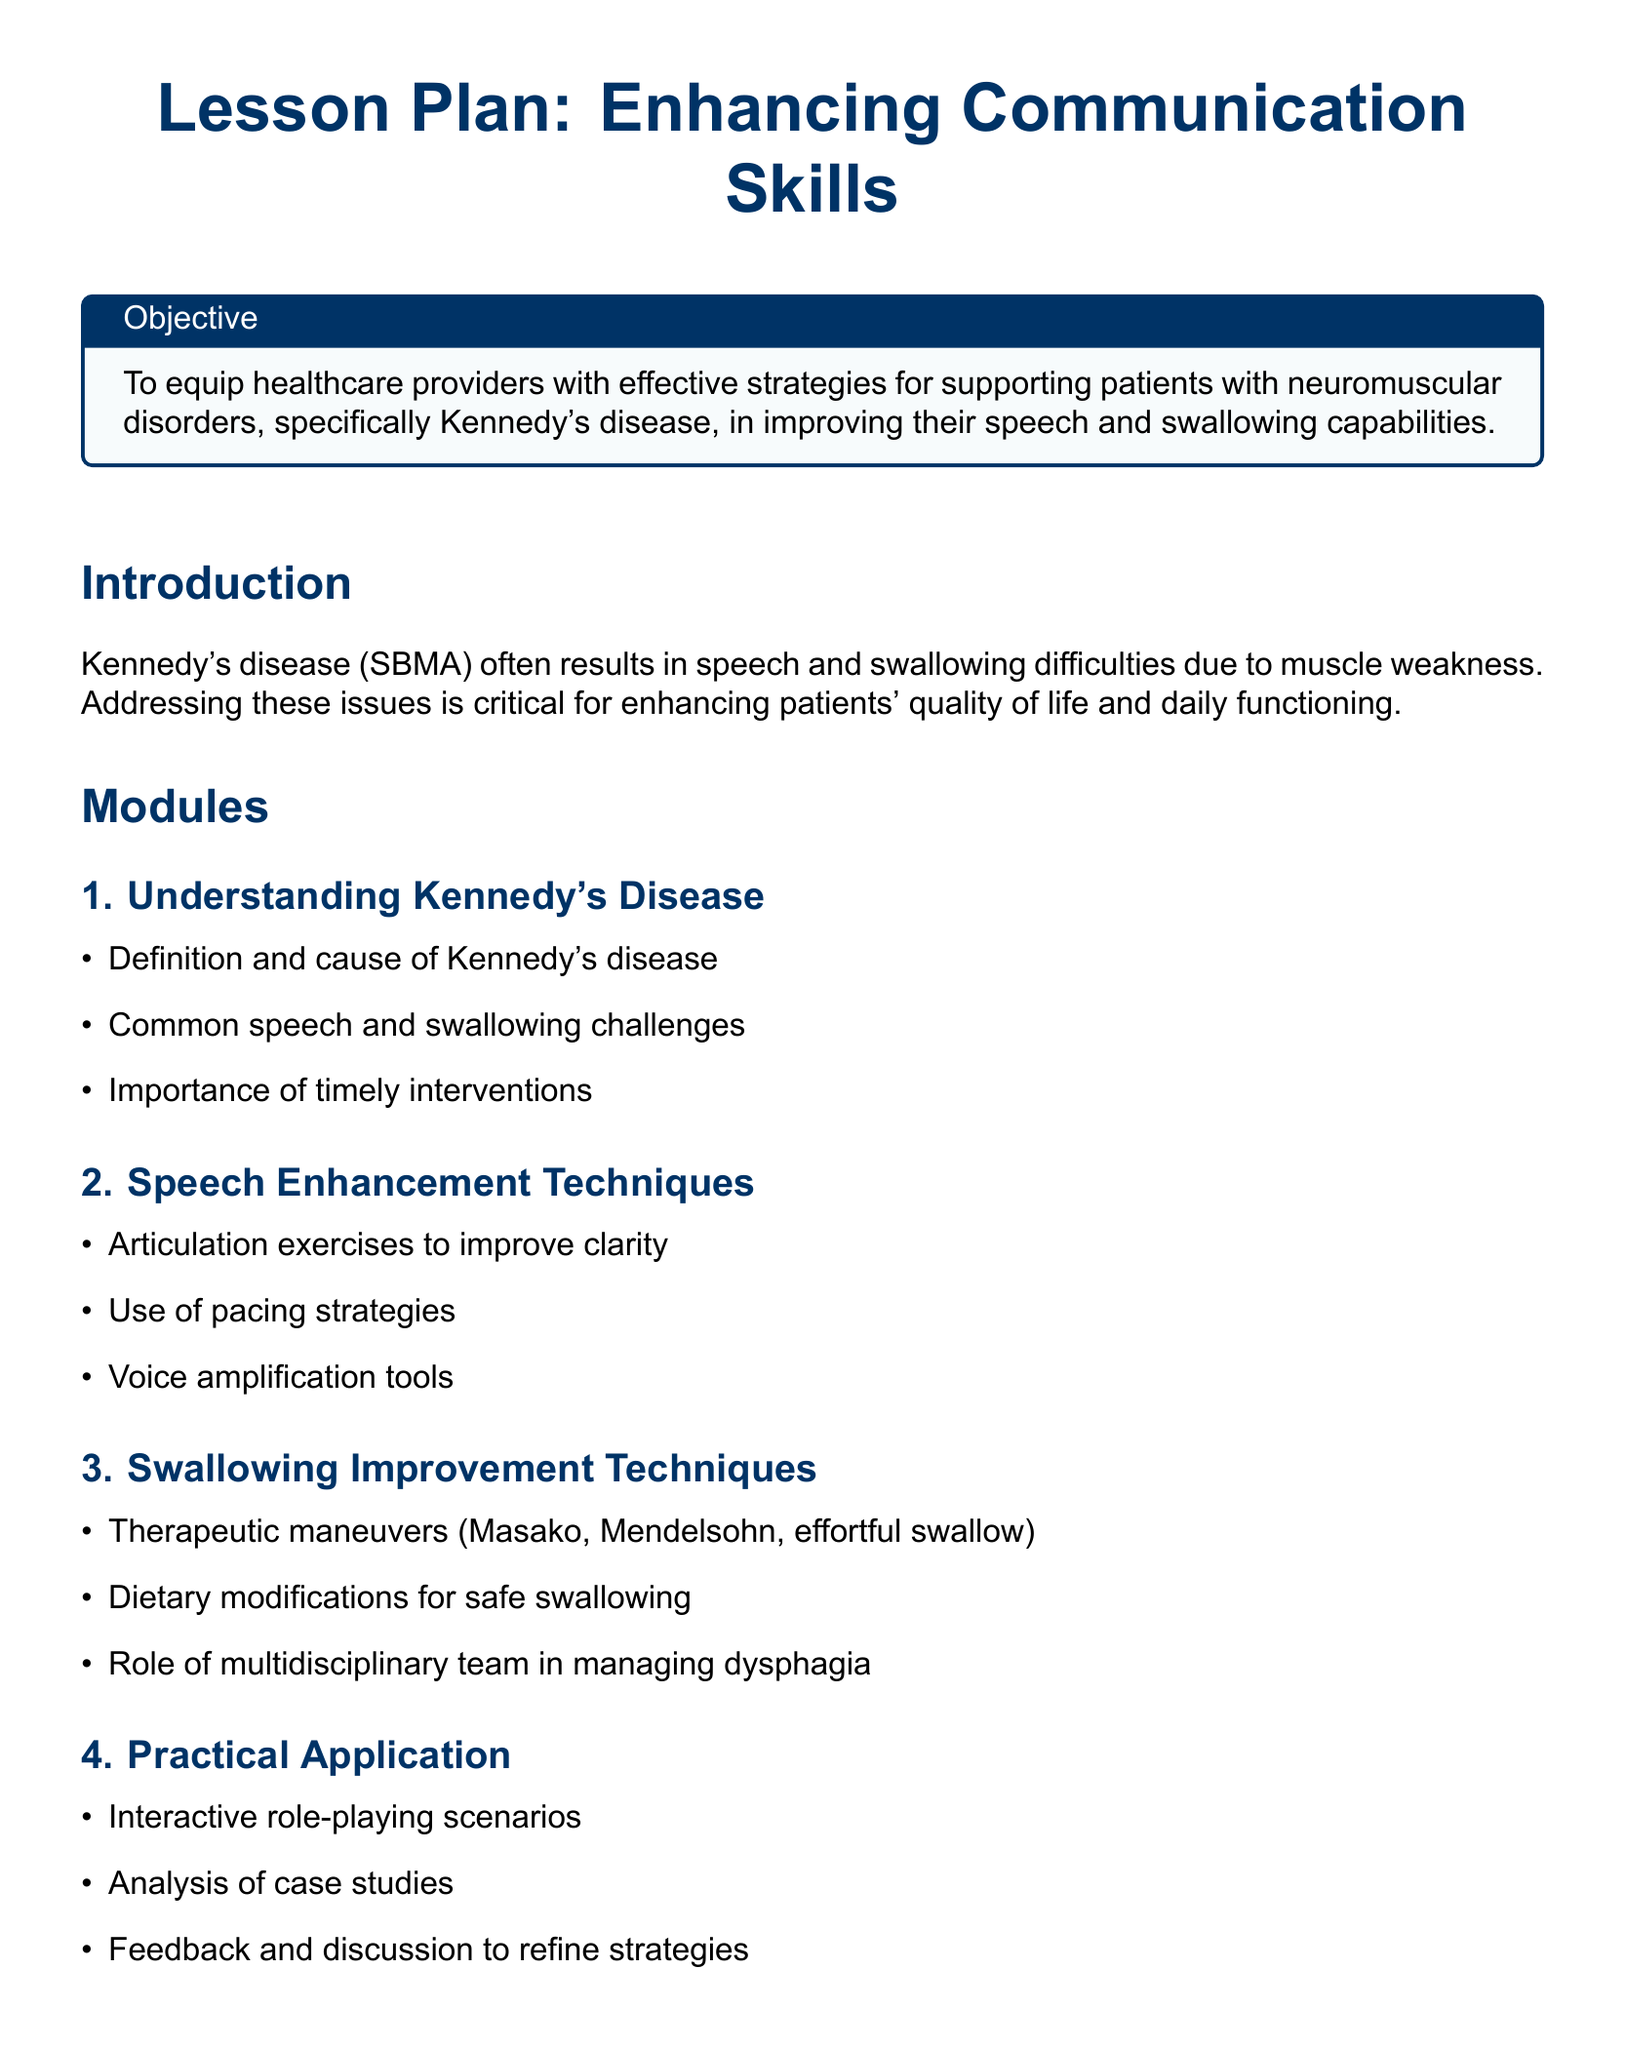What is the objective of the lesson plan? The objective outlines the goal of equipping healthcare providers with effective strategies for supporting patients with neuromuscular disorders.
Answer: To equip healthcare providers with effective strategies for supporting patients with neuromuscular disorders, specifically Kennedy's disease, in improving their speech and swallowing capabilities What is one of the common challenges faced by patients with Kennedy's disease? The document lists that patients often have speech and swallowing difficulties, which are primary challenges associated with Kennedy's disease.
Answer: Speech and swallowing difficulties What therapeutic maneuver is mentioned in the swallowing improvement techniques? The document specifies several therapeutic maneuvers like Masako and Mendelsohn for improving swallowing.
Answer: Masako How many modules are included in the lesson plan? The lesson plan contains four distinct modules that cover various aspects of communication skills.
Answer: 4 What is a recommended tool for voice enhancement in the speech enhancement techniques? The document refers to the use of voice amplification tools as a technique to support speech clarity.
Answer: Voice amplification tools What type of exercises are included in the speech enhancement techniques? The lesson focuses on articulation exercises, which are designed to help improve speech clarity.
Answer: Articulation exercises What does the conclusion emphasize about the techniques taught in the lesson plan? The conclusion states the importance of employing tailored speech and swallowing improvement techniques to enhance the patient's quality of life.
Answer: Enhance the quality of life What research journal is referenced regarding speech therapy interventions? The American Journal of Speech-Language Pathology is referenced as a key source for interventions related to speech therapy.
Answer: American Journal of Speech-Language Pathology 